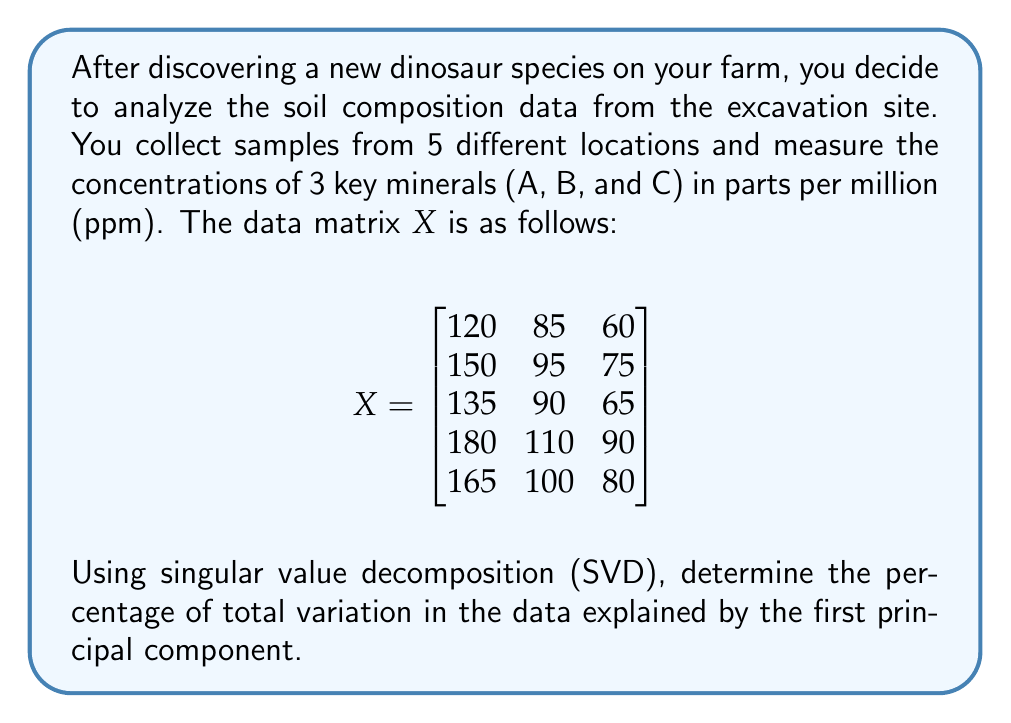Can you answer this question? To solve this problem, we'll follow these steps:

1) First, we need to perform SVD on matrix $X$. The SVD decomposes $X$ into three matrices:

   $$X = U\Sigma V^T$$

   Where $U$ and $V$ are orthogonal matrices, and $\Sigma$ is a diagonal matrix containing the singular values.

2) We don't need to calculate $U$ and $V$ explicitly. We're only interested in the singular values, which are the square roots of the eigenvalues of $X^TX$ or $XX^T$.

3) Let's calculate $X^TX$:

   $$X^TX = \begin{bmatrix}
   120 & 150 & 135 & 180 & 165 \\
   85 & 95 & 90 & 110 & 100 \\
   60 & 75 & 65 & 90 & 80
   \end{bmatrix} \begin{bmatrix}
   120 & 85 & 60 \\
   150 & 95 & 75 \\
   135 & 90 & 65 \\
   180 & 110 & 90 \\
   165 & 100 & 80
   \end{bmatrix} = \begin{bmatrix}
   111150 & 71475 & 56700 \\
   71475 & 46275 & 36600 \\
   56700 & 36600 & 29150
   \end{bmatrix}$$

4) Now, we need to find the eigenvalues of this matrix. The characteristic equation is:

   $$det(X^TX - \lambda I) = 0$$

   Solving this equation (which is a cubic equation in this case) gives us the eigenvalues:

   $$\lambda_1 \approx 185461.7, \lambda_2 \approx 1069.3, \lambda_3 \approx 44.0$$

5) The singular values are the square roots of these eigenvalues:

   $$\sigma_1 \approx 430.65, \sigma_2 \approx 32.70, \sigma_3 \approx 6.63$$

6) The total variation in the data is the sum of the squares of these singular values:

   $$\text{Total Variation} = \sigma_1^2 + \sigma_2^2 + \sigma_3^2 \approx 185461.7 + 1069.3 + 44.0 = 186575$$

7) The variation explained by the first principal component is $\sigma_1^2 = 185461.7$

8) Therefore, the percentage of total variation explained by the first principal component is:

   $$\frac{185461.7}{186575} \times 100\% \approx 99.40\%$$
Answer: 99.40% 